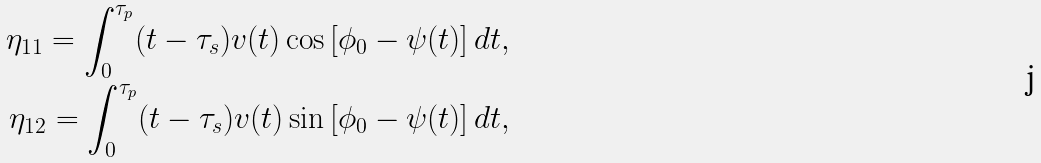<formula> <loc_0><loc_0><loc_500><loc_500>\eta _ { 1 1 } = \int _ { 0 } ^ { \tau _ { p } } ( t - \tau _ { s } ) v ( t ) \cos \left [ \phi _ { 0 } - \psi ( t ) \right ] d t , \\ \eta _ { 1 2 } = \int _ { 0 } ^ { \tau _ { p } } ( t - \tau _ { s } ) v ( t ) \sin \left [ \phi _ { 0 } - \psi ( t ) \right ] d t ,</formula> 